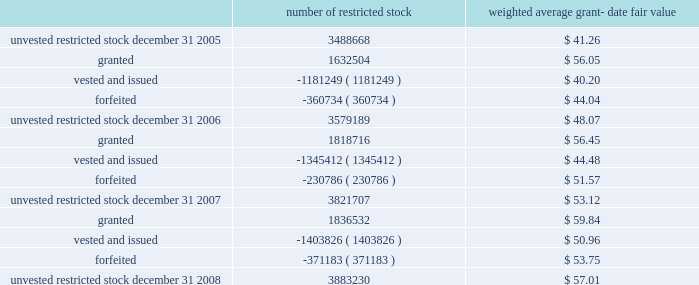N o t e s t o c o n s o l i d a t e d f i n a n c i a l s t a t e m e n t s ( continued ) ace limited and subsidiaries the table shows changes in the company 2019s restricted stock for the years ended december 31 , 2008 , 2007 , and 2006 : number of restricted stock weighted average grant- date fair value .
Under the provisions of fas 123r , the recognition of deferred compensation , a contra-equity account representing the amount of unrecognized restricted stock expense that is reduced as expense is recognized , at the date restricted stock is granted is no longer permitted .
Therefore , upon adoption of fas 123r , the amount of deferred compensation that had been reflected in unearned stock grant compensation was reclassified to additional paid-in capital in the company 2019s consolidated balance sheet .
Restricted stock units the company 2019s 2004 ltip also provides for grants of other awards , including restricted stock units .
The company generally grants restricted stock units with a 4-year vesting period , based on a graded vesting schedule .
Each restricted stock unit repre- sents the company 2019s obligation to deliver to the holder one share of common shares upon vesting .
During 2008 , the company awarded 223588 restricted stock units to officers of the company and its subsidiaries with a weighted-average grant date fair value of $ 59.93 .
During 2007 , 108870 restricted stock units , with a weighted-average grant date fair value of $ 56.29 were awarded to officers of the company and its subsidiaries .
During 2006 , 83370 restricted stock units , with a weighted-average grant date fair value of $ 56.36 were awarded to officers of the company and its subsidiaries .
The company also grants restricted stock units with a 1-year vesting period to non-management directors .
Delivery of common shares on account of these restricted stock units to non-management directors is deferred until six months after the date of the non-management directors 2019 termination from the board .
During 2008 , 2007 , and 2006 , 40362 restricted stock units , 29676 restricted stock units , and 23092 restricted stock units , respectively , were awarded to non-management direc- the espp gives participating employees the right to purchase common shares through payroll deductions during consecutive 201csubscription periods . 201d annual purchases by participants are limited to the number of whole shares that can be purchased by an amount equal to ten percent of the participant 2019s compensation or $ 25000 , whichever is less .
The espp has two six-month subscription periods , the first of which runs between january 1 and june 30 and the second of which runs between july 1 and december 31 of each year .
The amounts that have been collected from participants during a subscription period are used on the 201cexercise date 201d to purchase full shares of common shares .
An exercise date is generally the last trading day of a sub- scription period .
The number of shares purchased is equal to the total amount , as of the exercise date , that has been collected from the participants through payroll deductions for that subscription period , divided by the 201cpurchase price 201d , rounded down to the next full share .
Effective for and from the second subscription period of 2007 , the purchase price is 85 percent of the fair value of a common share on the exercise date .
Prior to the second subscription period of 2007 , the purchase price was calculated as the lower of ( i ) 85 percent of the fair value of a common share on the first day of the subscription period , or .
What is the net change in the number of unvested restricted stocks in 2008? 
Computations: (3883230 - 3821707)
Answer: 61523.0. 